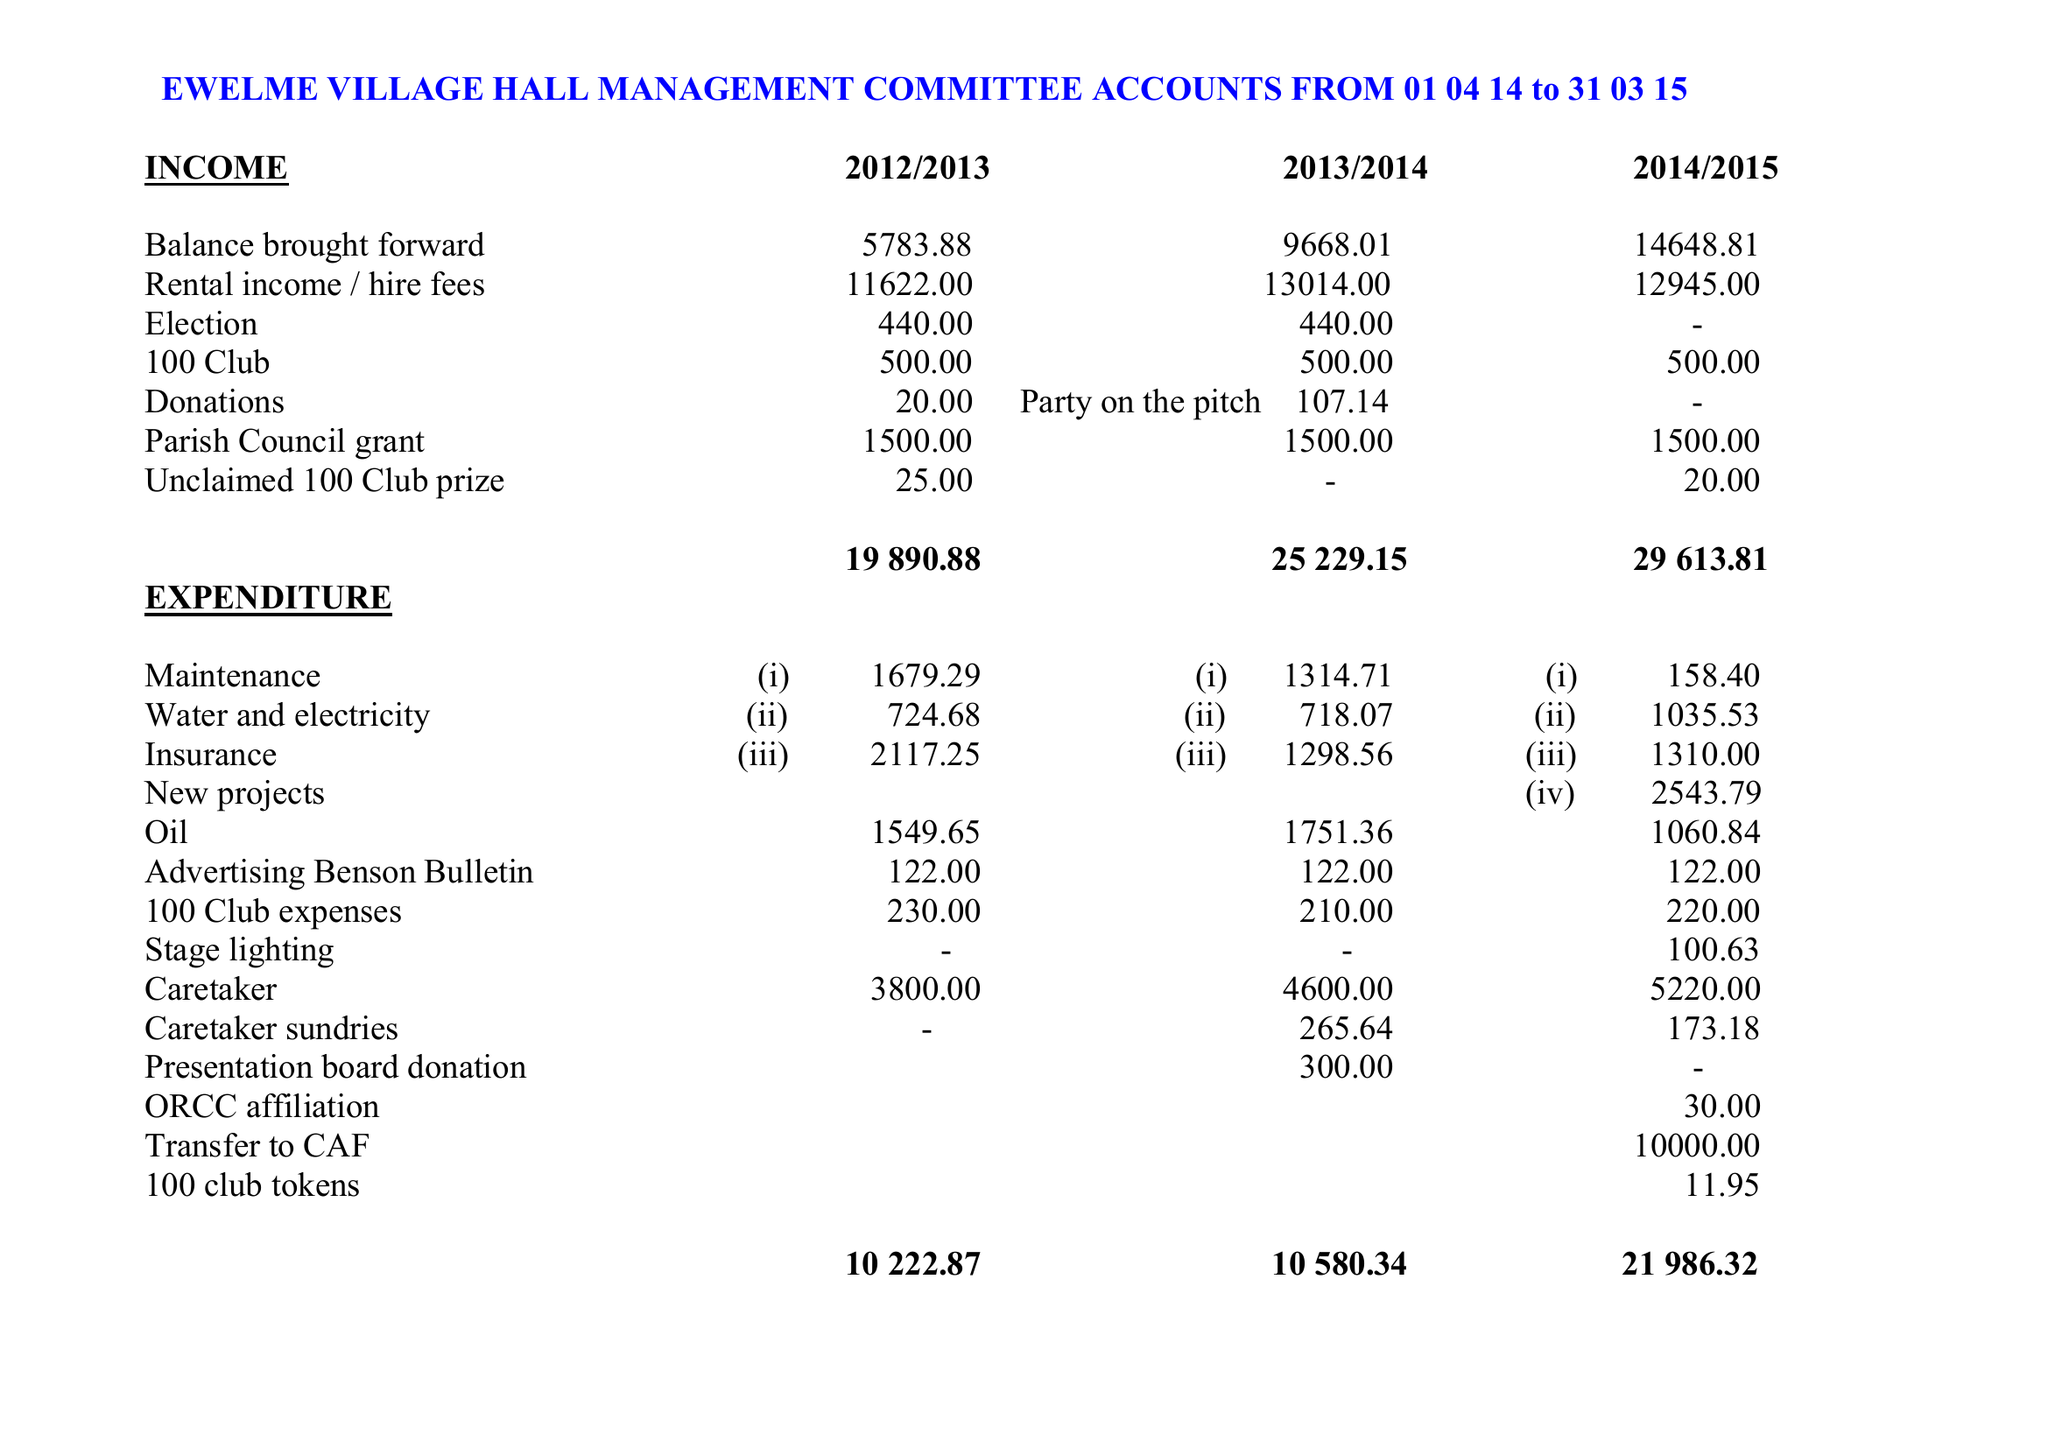What is the value for the income_annually_in_british_pounds?
Answer the question using a single word or phrase. 29613.00 